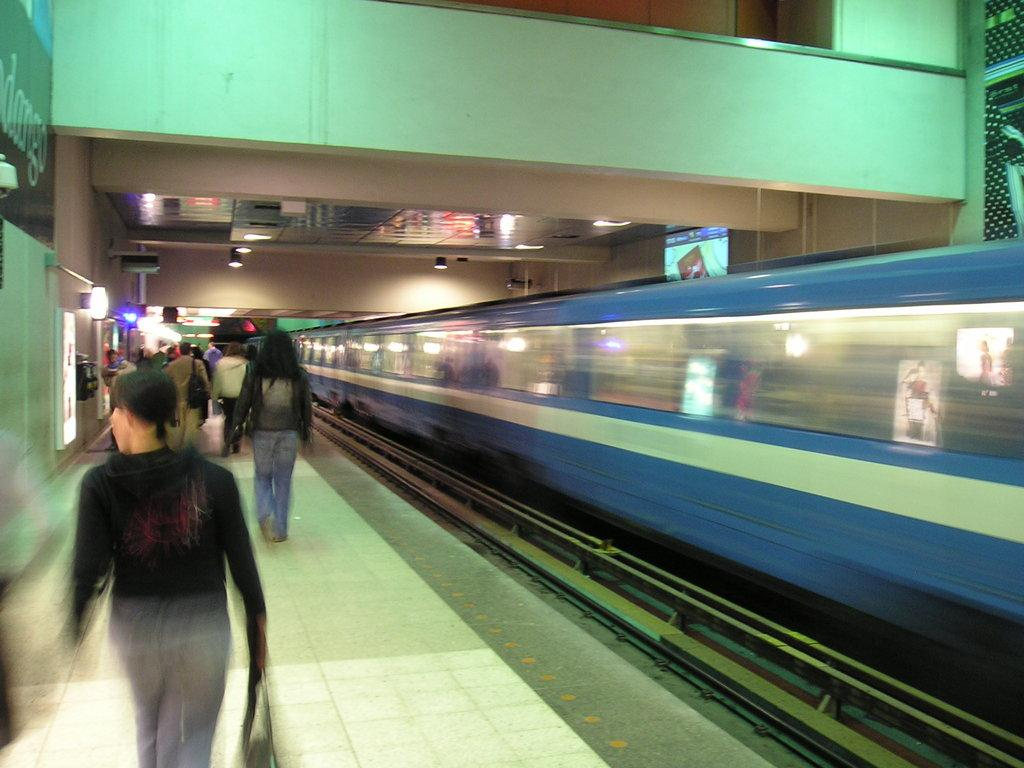What can be seen on the platform in the foreground of the image? There is a crowd on the platform in the foreground. What is located on the track in the foreground? There is a train on the track in the foreground. What architectural feature is visible at the top of the image? There is a bridge visible at the top of the image. What type of barrier is present in the image? There is a fence in the image. What time of day is depicted in the image? The image is taken during nighttime. What type of waste can be seen being disposed of in the image? There is no waste being disposed of in the image; it primarily features a crowd, a train, a bridge, a fence, and the nighttime setting. 